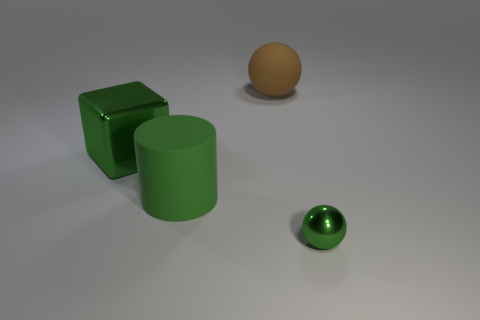Is there a large green object made of the same material as the small green sphere?
Provide a short and direct response. Yes. What is the material of the brown ball that is the same size as the green matte object?
Give a very brief answer. Rubber. What number of large green shiny objects are the same shape as the small metallic object?
Offer a terse response. 0. What size is the object that is the same material as the big cylinder?
Ensure brevity in your answer.  Large. What material is the object that is both right of the rubber cylinder and left of the small green ball?
Your answer should be very brief. Rubber. What number of green cylinders have the same size as the shiny ball?
Give a very brief answer. 0. What material is the large brown object that is the same shape as the small metallic thing?
Your response must be concise. Rubber. What number of things are green metallic objects in front of the green matte object or green objects behind the green metal ball?
Offer a terse response. 3. Do the tiny green metallic thing and the matte object that is in front of the big green shiny block have the same shape?
Keep it short and to the point. No. The thing to the left of the matte object that is on the left side of the thing behind the large metallic block is what shape?
Ensure brevity in your answer.  Cube. 